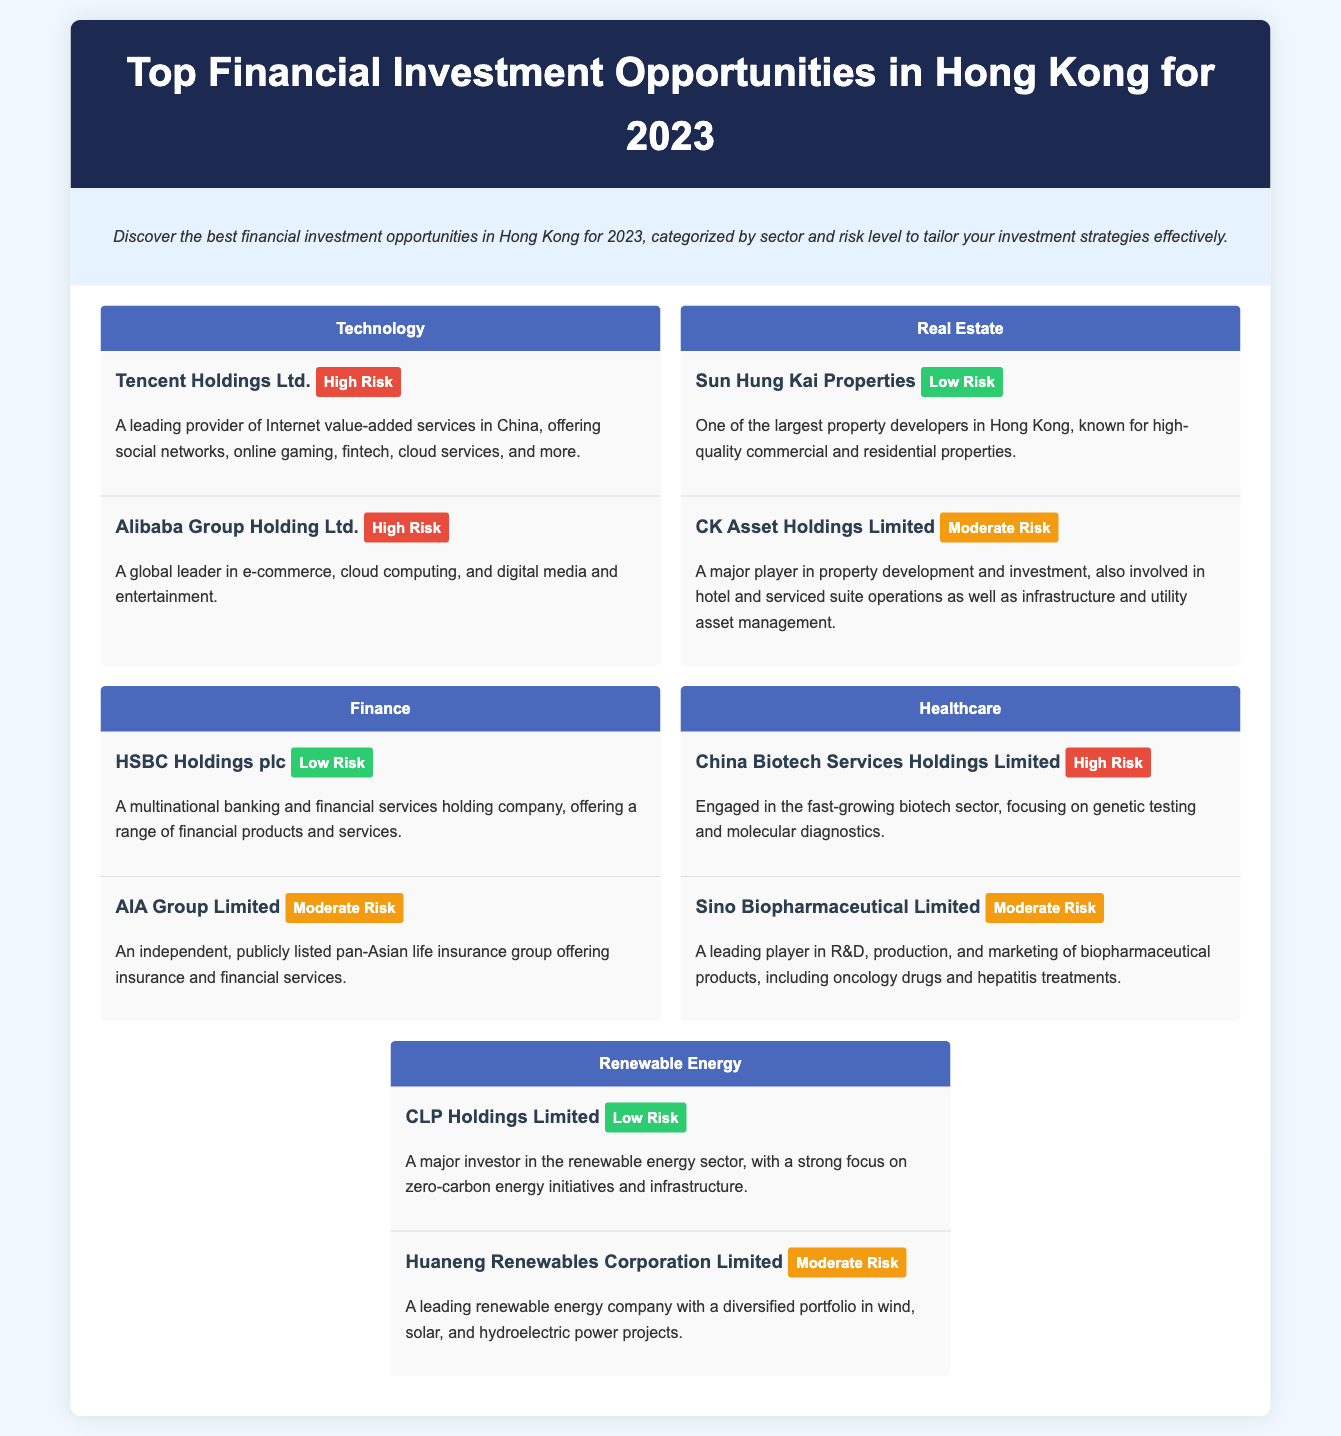What is the title of the document? The title displayed in the header of the document is the main identifier for its content.
Answer: Top Financial Investment Opportunities in Hong Kong for 2023 How many sectors are listed in the document? Each distinct sector, such as Technology, Real Estate, Finance, Healthcare, and Renewable Energy, contributes to the total count.
Answer: 5 Which company has a low-risk rating in the Technology sector? The question focuses on identifying the specific company categorized by sector and risk level.
Answer: None What type of services does Tencent Holdings Ltd. provide? The answer requires understanding the business operations described in the document related to Tencent Holdings.
Answer: Internet value-added services Which company is associated with high risk in the healthcare sector? This question asks for a specific company that aligns with the high-risk classification in the healthcare sector.
Answer: China Biotech Services Holdings Limited What is the risk level of HSBC Holdings plc? This identifies HSBC Holdings plc's classification in terms of investment risk, as denoted within the document.
Answer: Low Risk Which sector does Huaneng Renewables Corporation Limited belong to? The answer requires recognizing the sector associated with the specific company mentioned in the document.
Answer: Renewable Energy How many opportunities are listed under the Real Estate sector? This finds the total number of investment opportunities specifically mentioned in the Real Estate sector.
Answer: 2 What investment opportunity is characterized as a multinational banking service provider? This question seeks to identify the specific type of company noted for its fiscal services discussed in the document.
Answer: HSBC Holdings plc What company is described as one of the largest property developers in Hong Kong? This question identifies a specific company's capabilities as outlined in the Real Estate section of the document.
Answer: Sun Hung Kai Properties 